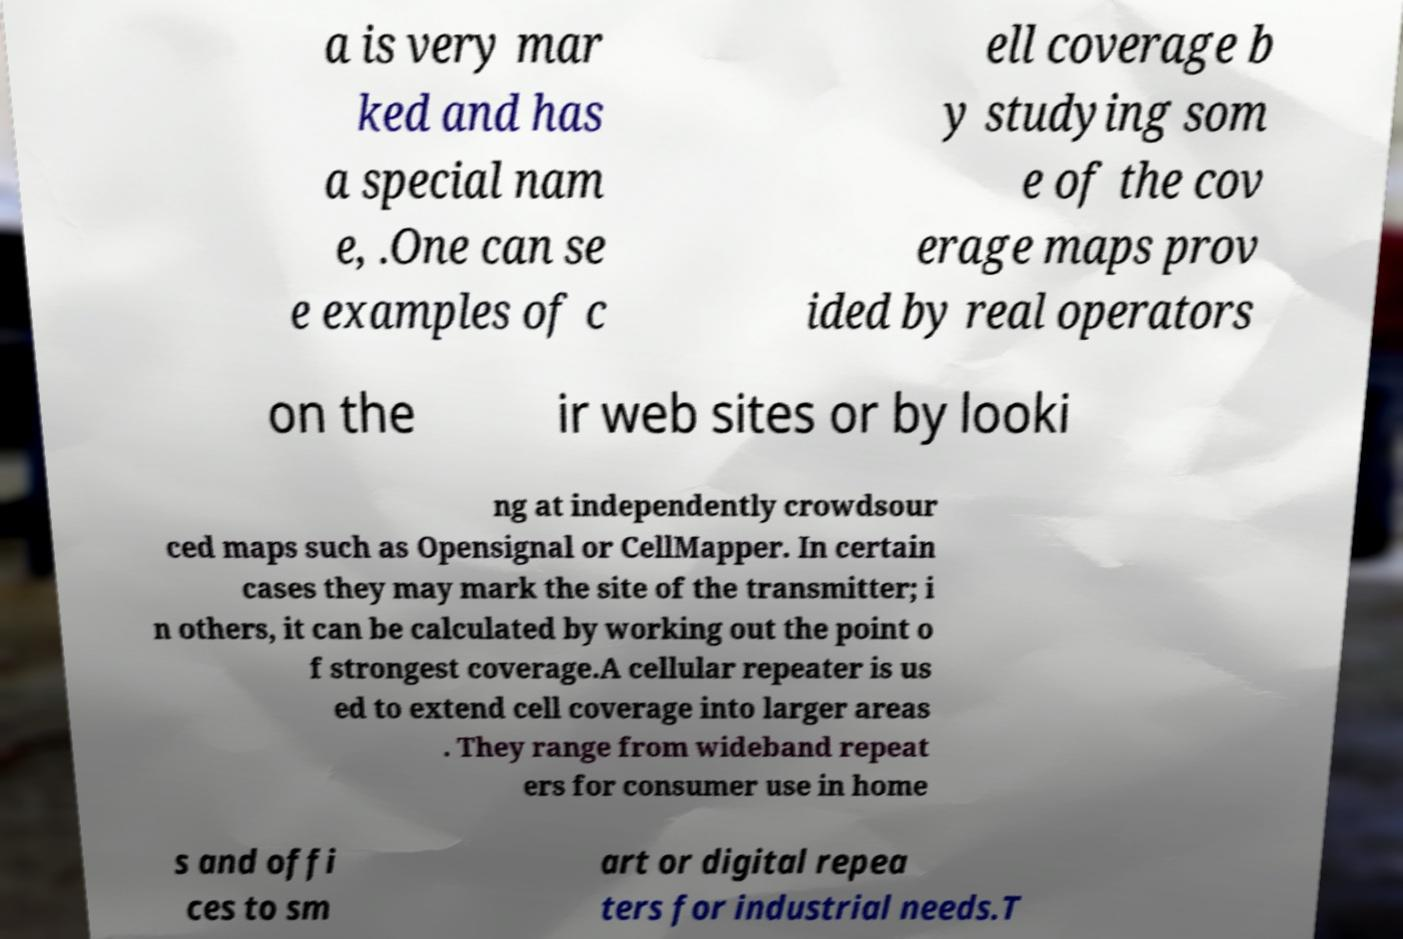I need the written content from this picture converted into text. Can you do that? a is very mar ked and has a special nam e, .One can se e examples of c ell coverage b y studying som e of the cov erage maps prov ided by real operators on the ir web sites or by looki ng at independently crowdsour ced maps such as Opensignal or CellMapper. In certain cases they may mark the site of the transmitter; i n others, it can be calculated by working out the point o f strongest coverage.A cellular repeater is us ed to extend cell coverage into larger areas . They range from wideband repeat ers for consumer use in home s and offi ces to sm art or digital repea ters for industrial needs.T 